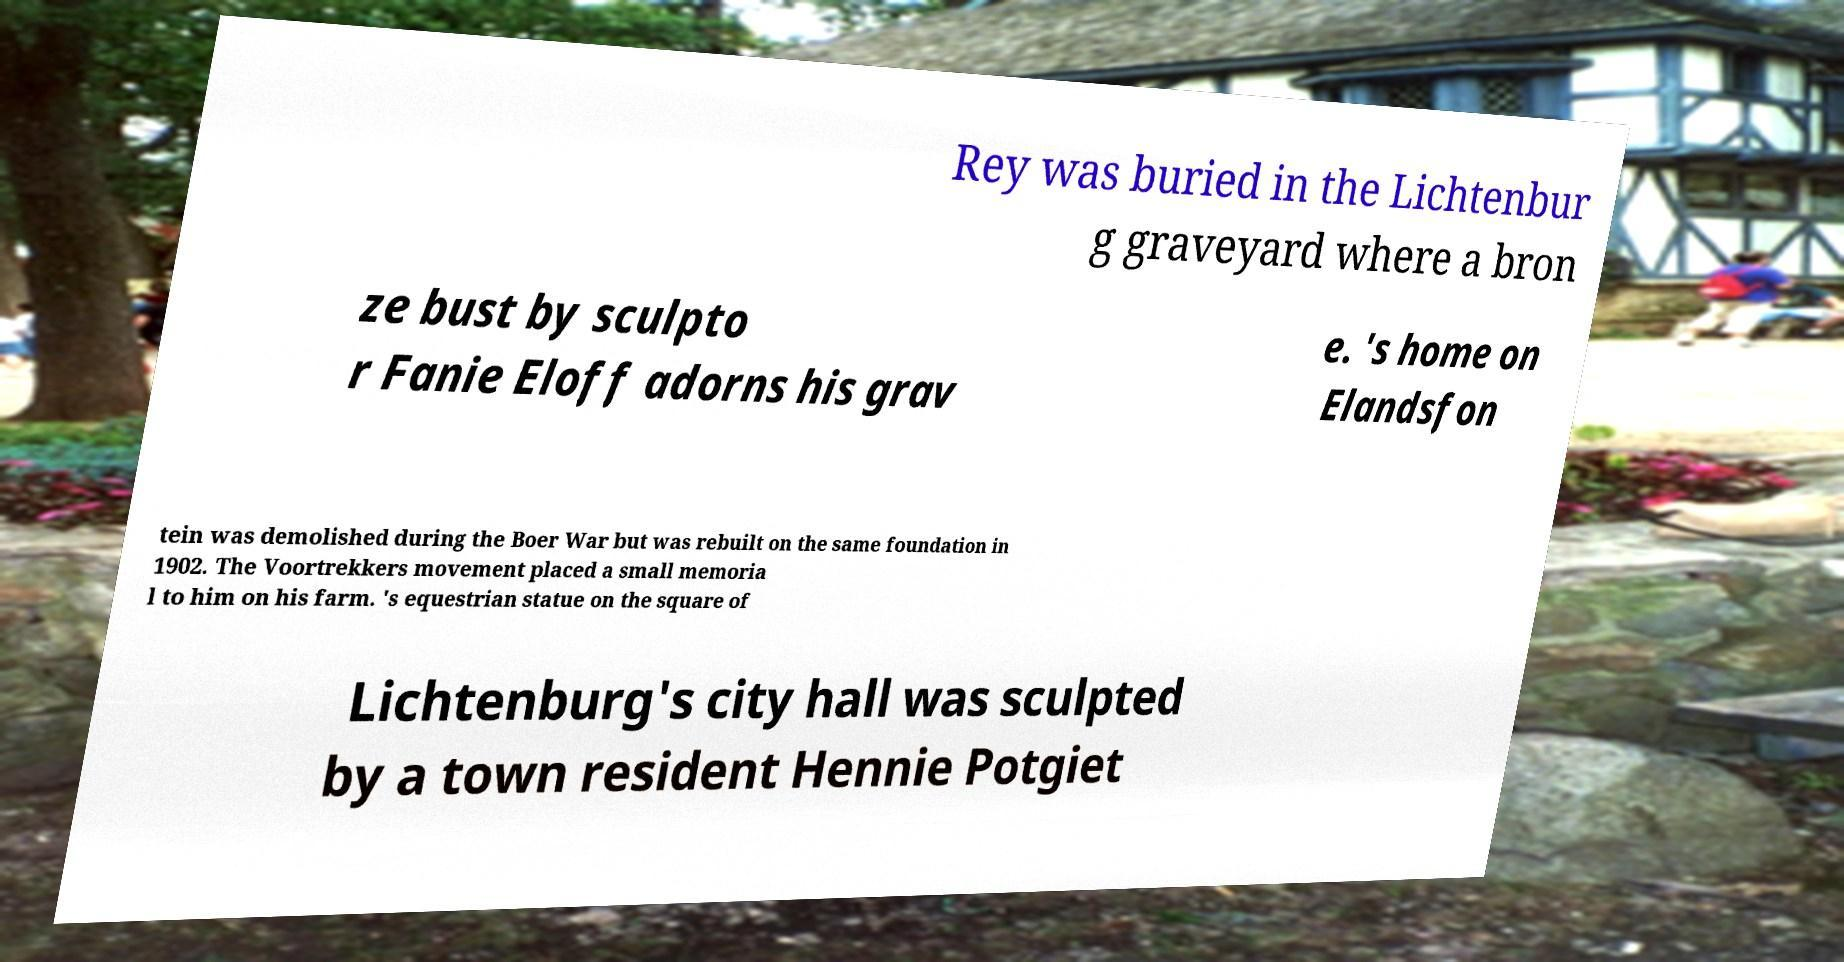Could you extract and type out the text from this image? Rey was buried in the Lichtenbur g graveyard where a bron ze bust by sculpto r Fanie Eloff adorns his grav e. 's home on Elandsfon tein was demolished during the Boer War but was rebuilt on the same foundation in 1902. The Voortrekkers movement placed a small memoria l to him on his farm. 's equestrian statue on the square of Lichtenburg's city hall was sculpted by a town resident Hennie Potgiet 